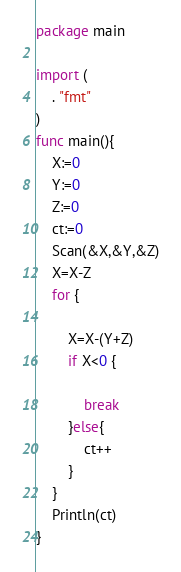Convert code to text. <code><loc_0><loc_0><loc_500><loc_500><_Go_>package main

import (
	. "fmt"
)
func main(){
	X:=0
	Y:=0
	Z:=0
	ct:=0
	Scan(&X,&Y,&Z)
	X=X-Z
	for {

		X=X-(Y+Z)
		if X<0 {
			
			break
		}else{
			ct++
		}
	}
	Println(ct)
}</code> 